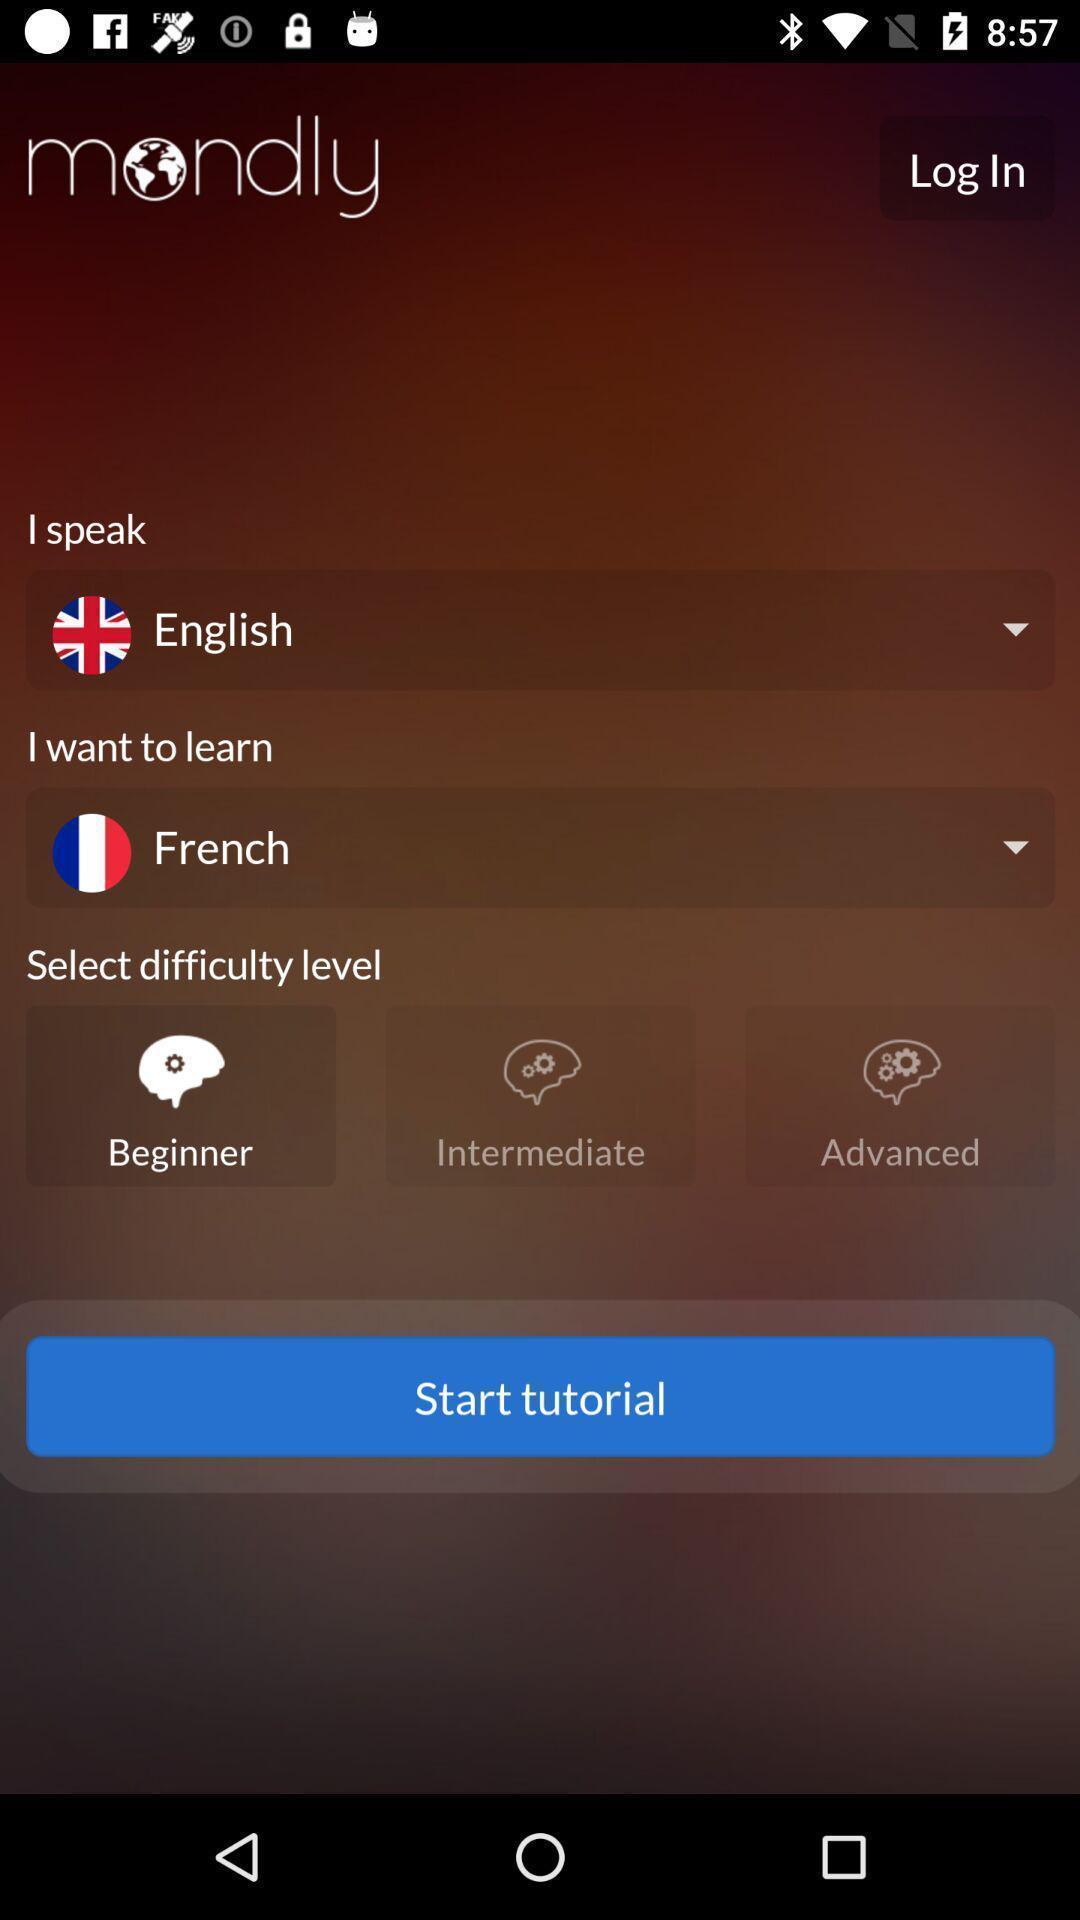Provide a description of this screenshot. Tutorial application to learn different languages. 